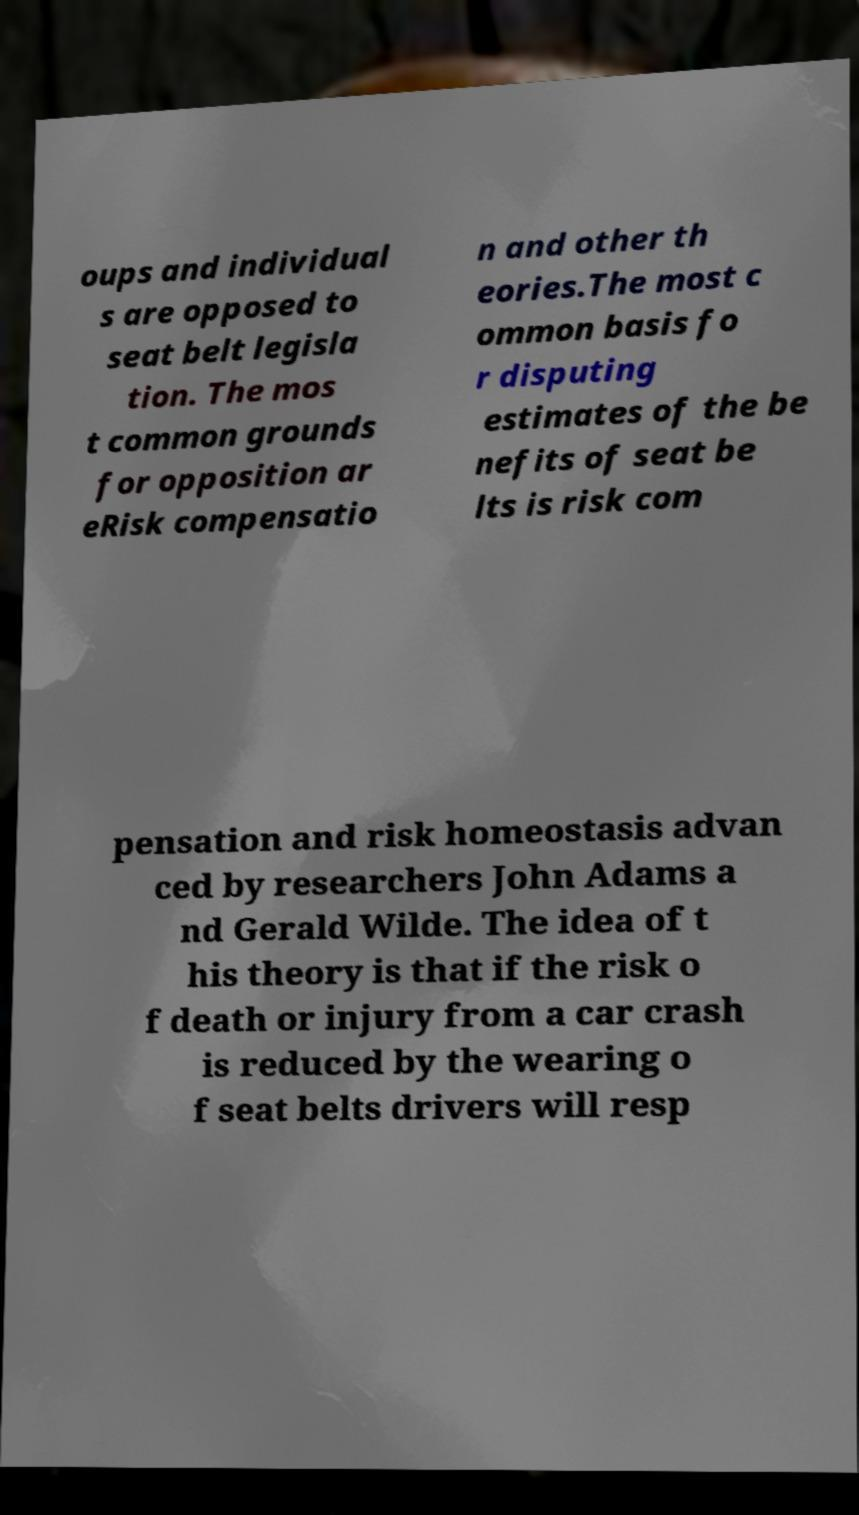Can you read and provide the text displayed in the image?This photo seems to have some interesting text. Can you extract and type it out for me? oups and individual s are opposed to seat belt legisla tion. The mos t common grounds for opposition ar eRisk compensatio n and other th eories.The most c ommon basis fo r disputing estimates of the be nefits of seat be lts is risk com pensation and risk homeostasis advan ced by researchers John Adams a nd Gerald Wilde. The idea of t his theory is that if the risk o f death or injury from a car crash is reduced by the wearing o f seat belts drivers will resp 